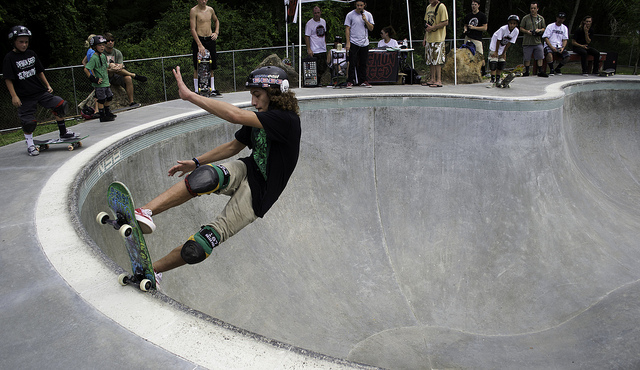What kind of maneuver might the skater be doing in this image? Based on the skater's body position and placement in the bowl, it looks like they might be performing a frontside air or similar aerial trick. 